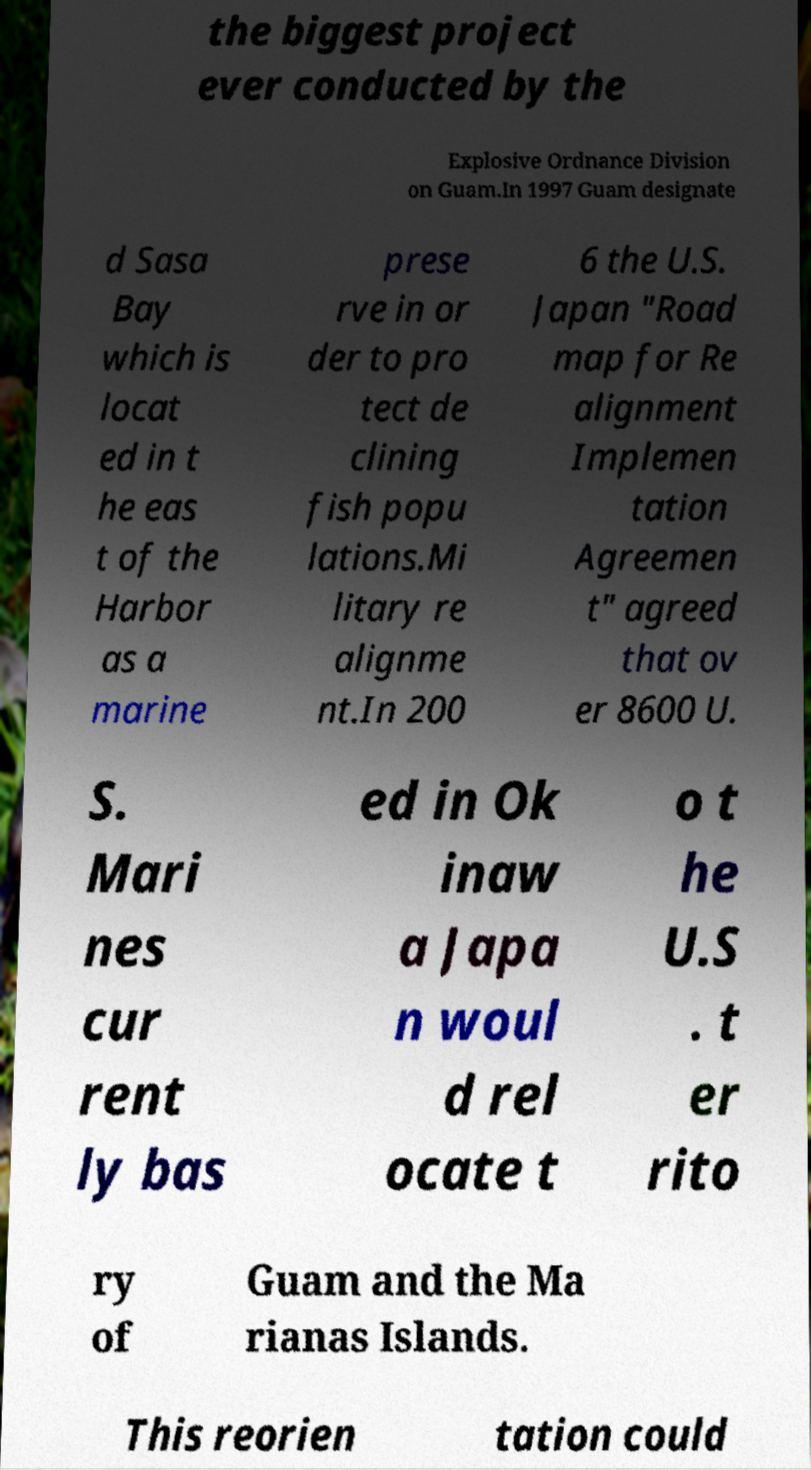Please identify and transcribe the text found in this image. the biggest project ever conducted by the Explosive Ordnance Division on Guam.In 1997 Guam designate d Sasa Bay which is locat ed in t he eas t of the Harbor as a marine prese rve in or der to pro tect de clining fish popu lations.Mi litary re alignme nt.In 200 6 the U.S. Japan "Road map for Re alignment Implemen tation Agreemen t" agreed that ov er 8600 U. S. Mari nes cur rent ly bas ed in Ok inaw a Japa n woul d rel ocate t o t he U.S . t er rito ry of Guam and the Ma rianas Islands. This reorien tation could 